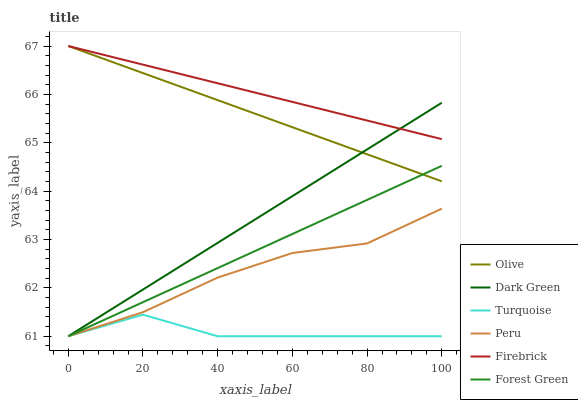Does Turquoise have the minimum area under the curve?
Answer yes or no. Yes. Does Firebrick have the maximum area under the curve?
Answer yes or no. Yes. Does Forest Green have the minimum area under the curve?
Answer yes or no. No. Does Forest Green have the maximum area under the curve?
Answer yes or no. No. Is Dark Green the smoothest?
Answer yes or no. Yes. Is Turquoise the roughest?
Answer yes or no. Yes. Is Firebrick the smoothest?
Answer yes or no. No. Is Firebrick the roughest?
Answer yes or no. No. Does Firebrick have the lowest value?
Answer yes or no. No. Does Olive have the highest value?
Answer yes or no. Yes. Does Forest Green have the highest value?
Answer yes or no. No. Is Turquoise less than Olive?
Answer yes or no. Yes. Is Firebrick greater than Peru?
Answer yes or no. Yes. Does Turquoise intersect Olive?
Answer yes or no. No. 